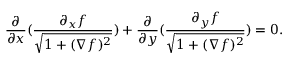<formula> <loc_0><loc_0><loc_500><loc_500>\frac { \partial } { \partial x } ( \frac { \partial _ { x } f } { \sqrt { 1 + ( \nabla f ) ^ { 2 } } } ) + \frac { \partial } { \partial y } ( \frac { \partial _ { y } f } { \sqrt { 1 + ( \nabla f ) ^ { 2 } } } ) = 0 .</formula> 